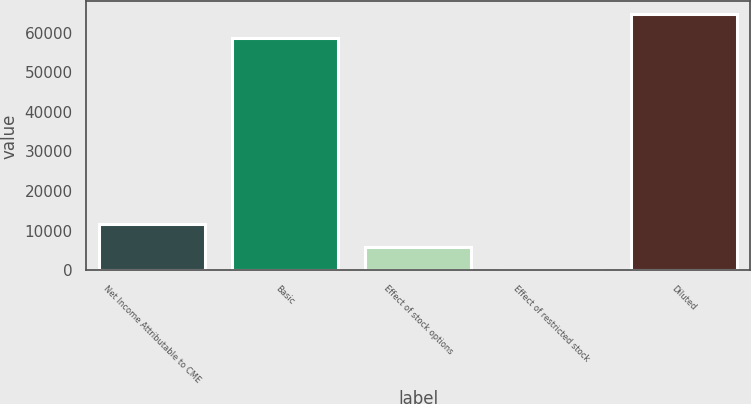Convert chart. <chart><loc_0><loc_0><loc_500><loc_500><bar_chart><fcel>Net Income Attributable to CME<fcel>Basic<fcel>Effect of stock options<fcel>Effect of restricted stock<fcel>Diluted<nl><fcel>11800.6<fcel>58738<fcel>5904.8<fcel>9<fcel>64633.8<nl></chart> 